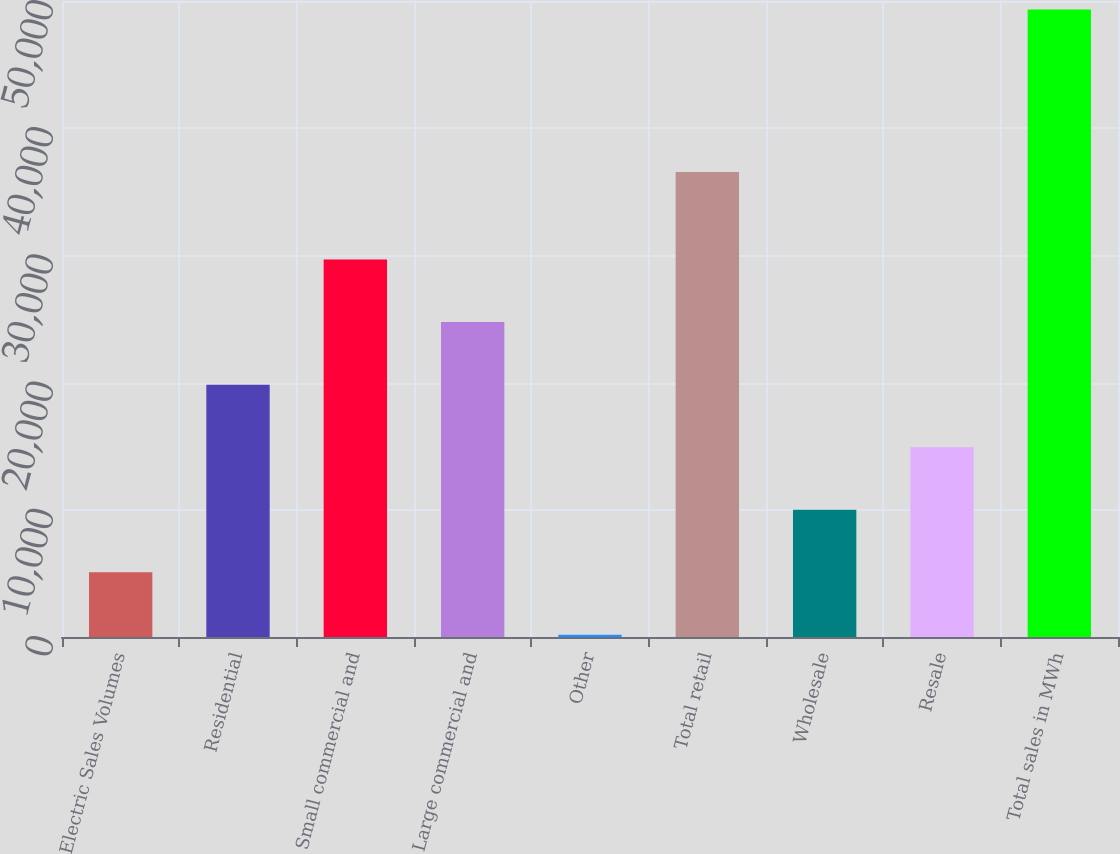Convert chart to OTSL. <chart><loc_0><loc_0><loc_500><loc_500><bar_chart><fcel>Electric Sales Volumes<fcel>Residential<fcel>Small commercial and<fcel>Large commercial and<fcel>Other<fcel>Total retail<fcel>Wholesale<fcel>Resale<fcel>Total sales in MWh<nl><fcel>5091.47<fcel>19839.1<fcel>29670.8<fcel>24755<fcel>175.6<fcel>36566<fcel>10007.3<fcel>14923.2<fcel>49334.3<nl></chart> 